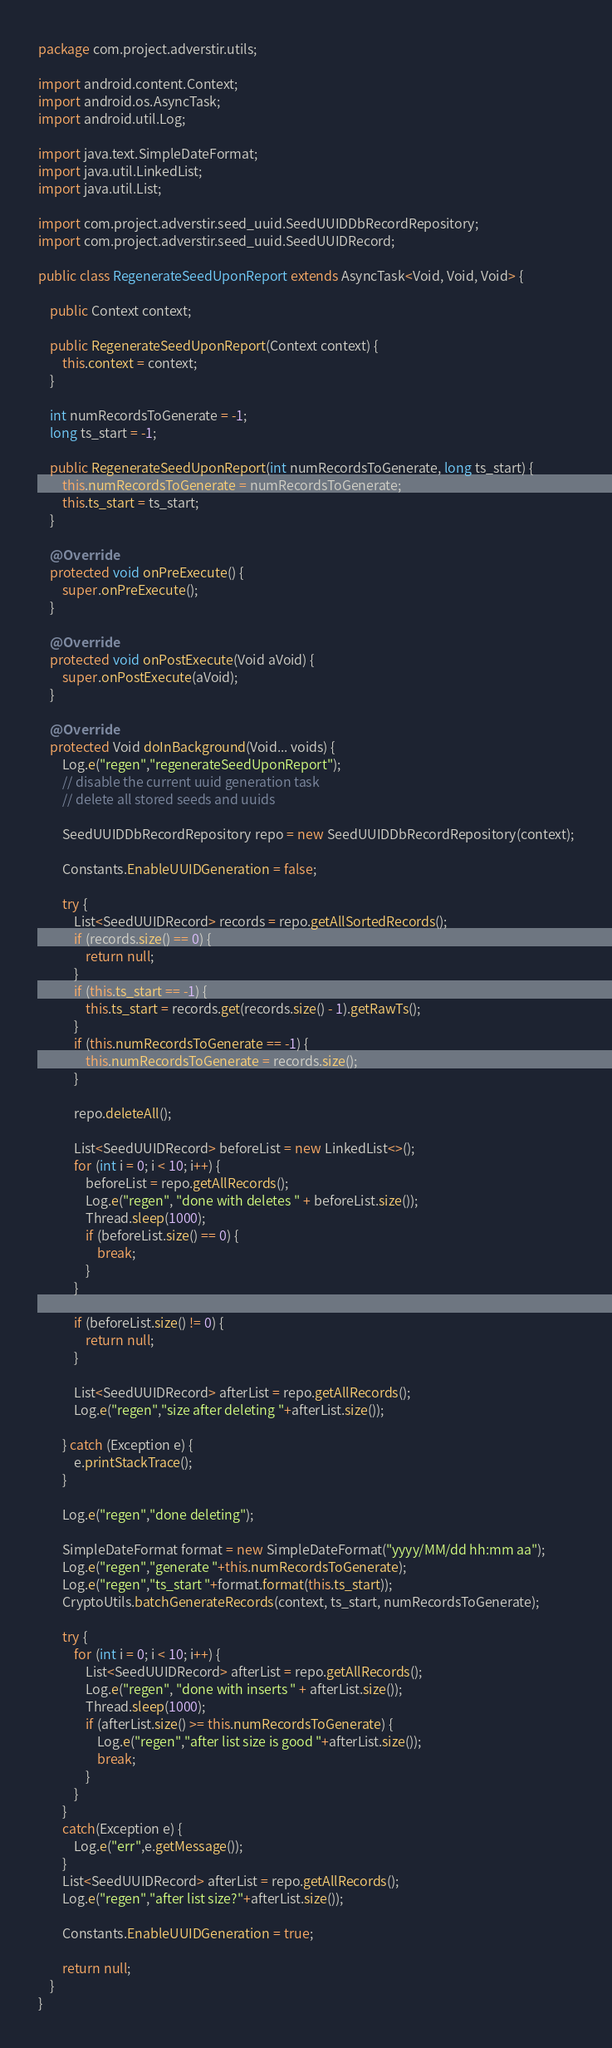Convert code to text. <code><loc_0><loc_0><loc_500><loc_500><_Java_>package com.project.adverstir.utils;

import android.content.Context;
import android.os.AsyncTask;
import android.util.Log;

import java.text.SimpleDateFormat;
import java.util.LinkedList;
import java.util.List;

import com.project.adverstir.seed_uuid.SeedUUIDDbRecordRepository;
import com.project.adverstir.seed_uuid.SeedUUIDRecord;

public class RegenerateSeedUponReport extends AsyncTask<Void, Void, Void> {

    public Context context;

    public RegenerateSeedUponReport(Context context) {
        this.context = context;
    }

    int numRecordsToGenerate = -1;
    long ts_start = -1;

    public RegenerateSeedUponReport(int numRecordsToGenerate, long ts_start) {
        this.numRecordsToGenerate = numRecordsToGenerate;
        this.ts_start = ts_start;
    }

    @Override
    protected void onPreExecute() {
        super.onPreExecute();
    }

    @Override
    protected void onPostExecute(Void aVoid) {
        super.onPostExecute(aVoid);
    }

    @Override
    protected Void doInBackground(Void... voids) {
        Log.e("regen","regenerateSeedUponReport");
        // disable the current uuid generation task
        // delete all stored seeds and uuids

        SeedUUIDDbRecordRepository repo = new SeedUUIDDbRecordRepository(context);

        Constants.EnableUUIDGeneration = false;

        try {
            List<SeedUUIDRecord> records = repo.getAllSortedRecords();
            if (records.size() == 0) {
                return null;
            }
            if (this.ts_start == -1) {
                this.ts_start = records.get(records.size() - 1).getRawTs();
            }
            if (this.numRecordsToGenerate == -1) {
                this.numRecordsToGenerate = records.size();
            }

            repo.deleteAll();

            List<SeedUUIDRecord> beforeList = new LinkedList<>();
            for (int i = 0; i < 10; i++) {
                beforeList = repo.getAllRecords();
                Log.e("regen", "done with deletes " + beforeList.size());
                Thread.sleep(1000);
                if (beforeList.size() == 0) {
                    break;
                }
            }

            if (beforeList.size() != 0) {
                return null;
            }

            List<SeedUUIDRecord> afterList = repo.getAllRecords();
            Log.e("regen","size after deleting "+afterList.size());

        } catch (Exception e) {
            e.printStackTrace();
        }

        Log.e("regen","done deleting");

        SimpleDateFormat format = new SimpleDateFormat("yyyy/MM/dd hh:mm aa");
        Log.e("regen","generate "+this.numRecordsToGenerate);
        Log.e("regen","ts_start "+format.format(this.ts_start));
        CryptoUtils.batchGenerateRecords(context, ts_start, numRecordsToGenerate);

        try {
            for (int i = 0; i < 10; i++) {
                List<SeedUUIDRecord> afterList = repo.getAllRecords();
                Log.e("regen", "done with inserts " + afterList.size());
                Thread.sleep(1000);
                if (afterList.size() >= this.numRecordsToGenerate) {
                    Log.e("regen","after list size is good "+afterList.size());
                    break;
                }
            }
        }
        catch(Exception e) {
            Log.e("err",e.getMessage());
        }
        List<SeedUUIDRecord> afterList = repo.getAllRecords();
        Log.e("regen","after list size?"+afterList.size());

        Constants.EnableUUIDGeneration = true;

        return null;
    }
}
</code> 